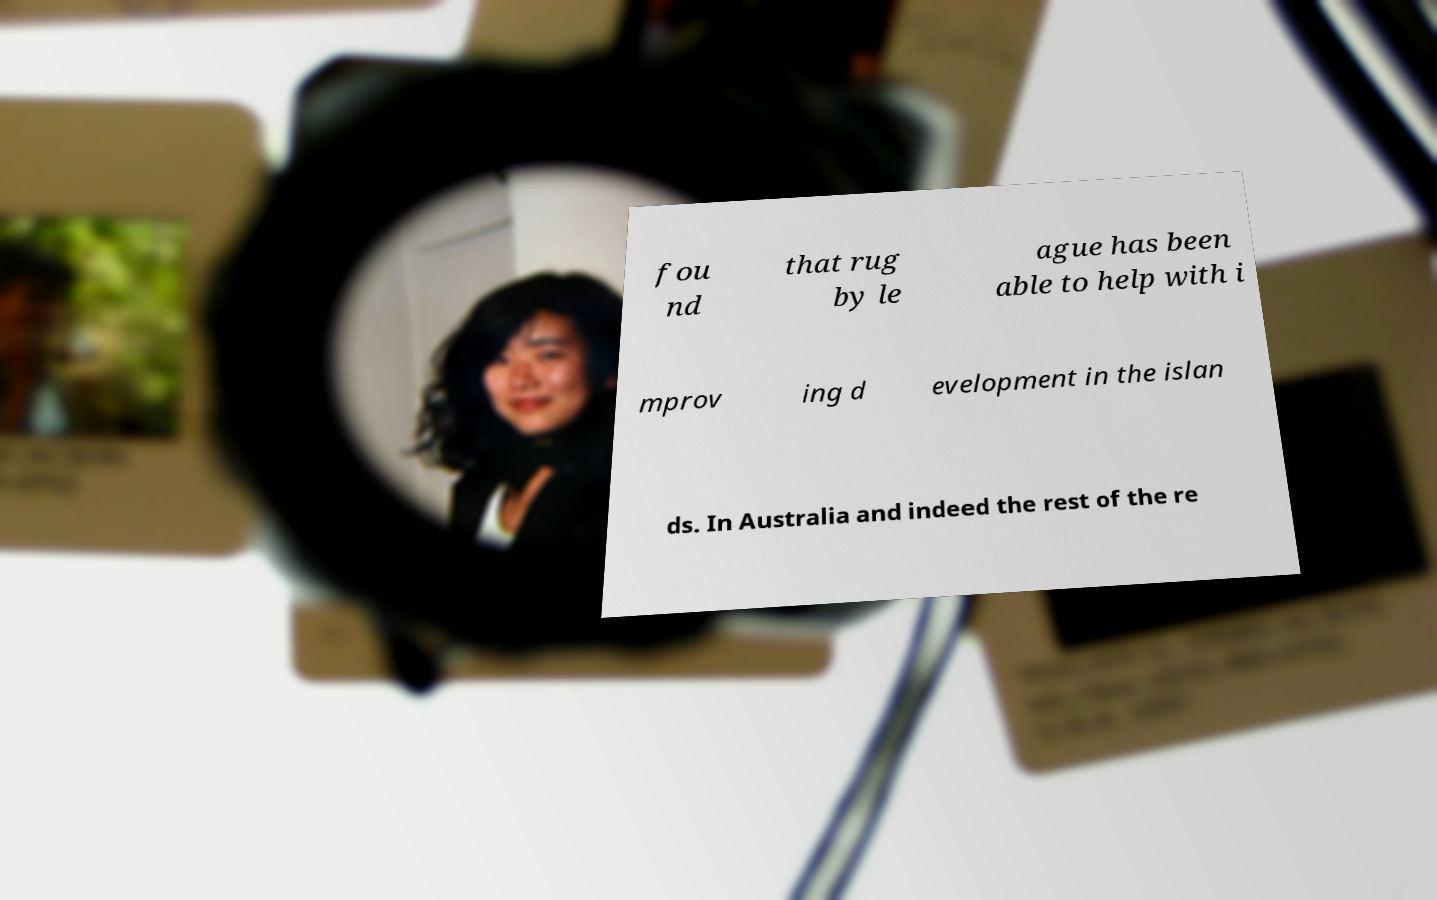Please identify and transcribe the text found in this image. fou nd that rug by le ague has been able to help with i mprov ing d evelopment in the islan ds. In Australia and indeed the rest of the re 